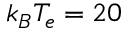Convert formula to latex. <formula><loc_0><loc_0><loc_500><loc_500>k _ { B } T _ { e } = 2 0</formula> 